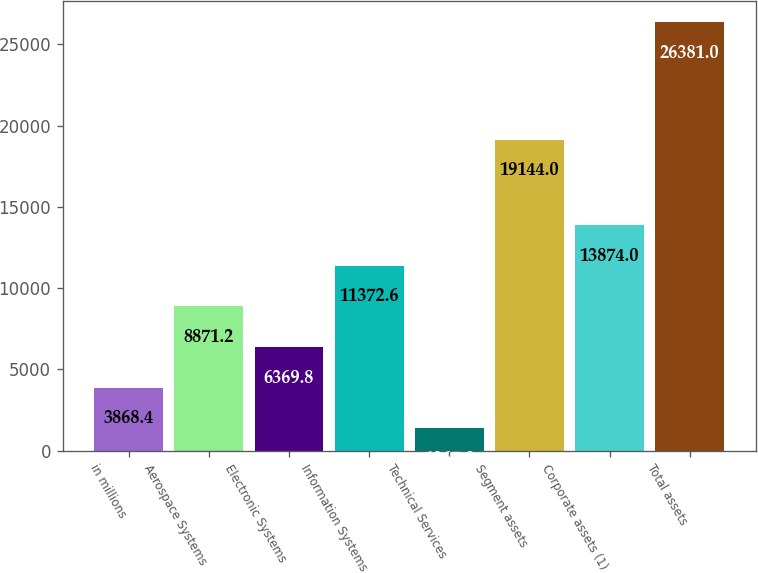Convert chart. <chart><loc_0><loc_0><loc_500><loc_500><bar_chart><fcel>in millions<fcel>Aerospace Systems<fcel>Electronic Systems<fcel>Information Systems<fcel>Technical Services<fcel>Segment assets<fcel>Corporate assets (1)<fcel>Total assets<nl><fcel>3868.4<fcel>8871.2<fcel>6369.8<fcel>11372.6<fcel>1367<fcel>19144<fcel>13874<fcel>26381<nl></chart> 